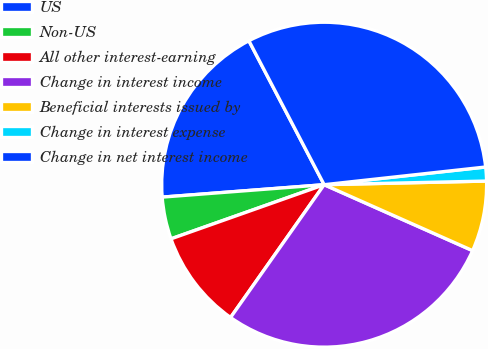<chart> <loc_0><loc_0><loc_500><loc_500><pie_chart><fcel>US<fcel>Non-US<fcel>All other interest-earning<fcel>Change in interest income<fcel>Beneficial interests issued by<fcel>Change in interest expense<fcel>Change in net interest income<nl><fcel>18.55%<fcel>4.19%<fcel>9.82%<fcel>28.12%<fcel>7.01%<fcel>1.38%<fcel>30.93%<nl></chart> 